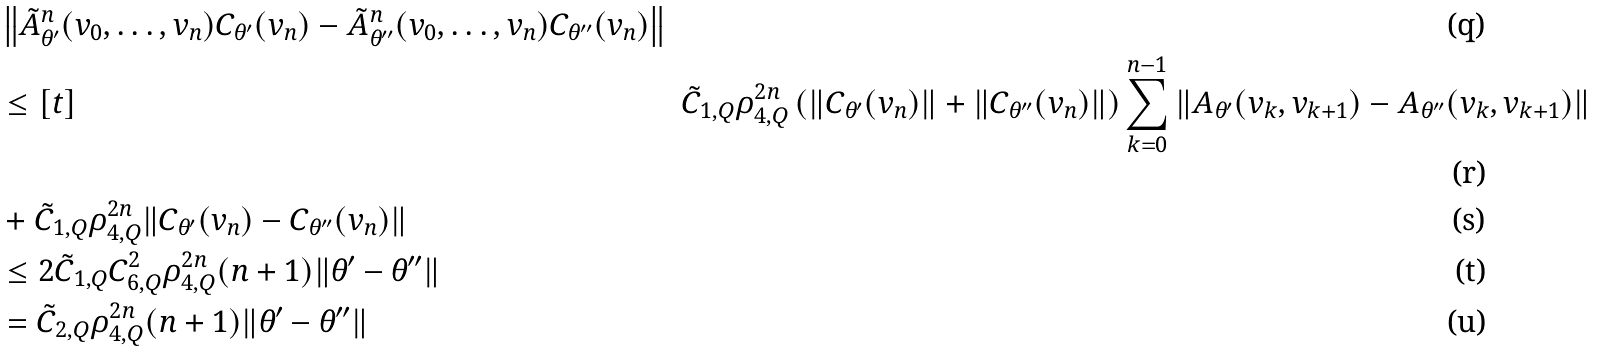Convert formula to latex. <formula><loc_0><loc_0><loc_500><loc_500>& \left \| \tilde { A } _ { \theta ^ { \prime } } ^ { n } ( v _ { 0 } , \dots , v _ { n } ) C _ { \theta ^ { \prime } } ( v _ { n } ) - \tilde { A } _ { \theta ^ { \prime \prime } } ^ { n } ( v _ { 0 } , \dots , v _ { n } ) C _ { \theta ^ { \prime \prime } } ( v _ { n } ) \right \| \\ & \leq [ t ] & \tilde { C } _ { 1 , Q } \rho _ { 4 , Q } ^ { 2 n } \left ( \| C _ { \theta ^ { \prime } } ( v _ { n } ) \| + \| C _ { \theta ^ { \prime \prime } } ( v _ { n } ) \| \right ) \sum _ { k = 0 } ^ { n - 1 } \| A _ { \theta ^ { \prime } } ( v _ { k } , v _ { k + 1 } ) - A _ { \theta ^ { \prime \prime } } ( v _ { k } , v _ { k + 1 } ) \| \\ & + \tilde { C } _ { 1 , Q } \rho _ { 4 , Q } ^ { 2 n } \| C _ { \theta ^ { \prime } } ( v _ { n } ) - C _ { \theta ^ { \prime \prime } } ( v _ { n } ) \| \\ & \leq 2 \tilde { C } _ { 1 , Q } C _ { 6 , Q } ^ { 2 } \rho _ { 4 , Q } ^ { 2 n } ( n + 1 ) \| \theta ^ { \prime } - \theta ^ { \prime \prime } \| \\ & = \tilde { C } _ { 2 , Q } \rho _ { 4 , Q } ^ { 2 n } ( n + 1 ) \| \theta ^ { \prime } - \theta ^ { \prime \prime } \|</formula> 